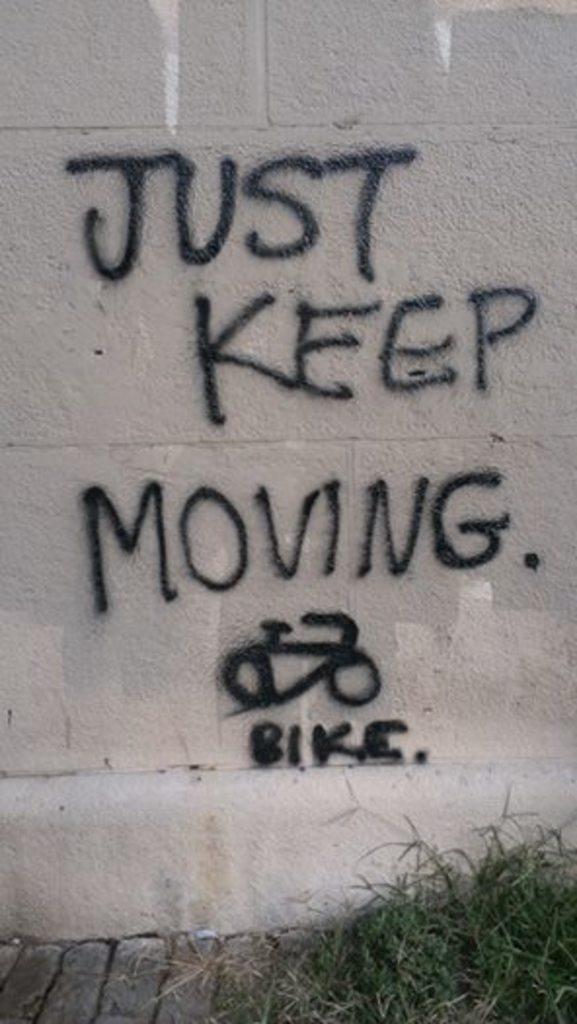In one or two sentences, can you explain what this image depicts? In this picture I can see the wall on which there is something written and I see the grass in front. 